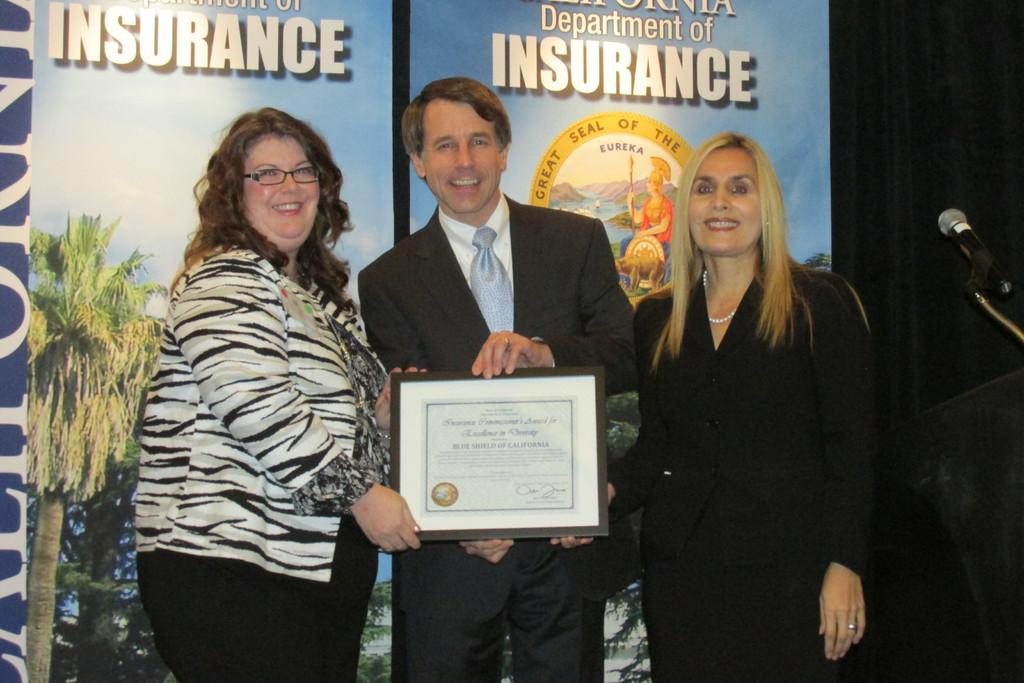How many people are in the image? There are three people standing and smiling in the image. What is the man holding in the image? The man is holding a frame in the image. What object is used for amplifying sound in the image? There is a microphone with a stand in the image. What can be seen in the background of the image? Banners are visible in the background, and the background is dark. Are there any giants visible in the image? No, there are no giants present in the image. What type of pain is the man experiencing in the image? There is no indication of pain in the image; the man is smiling and holding a frame. 